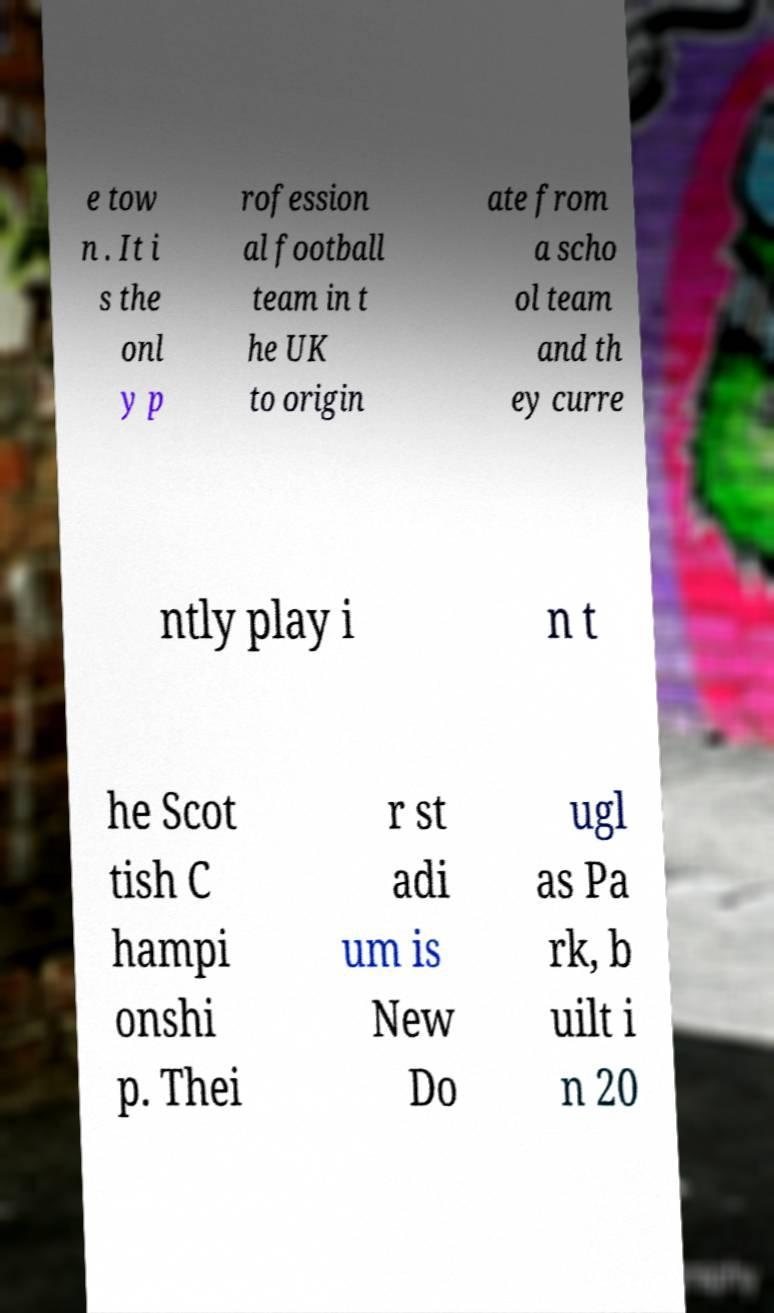For documentation purposes, I need the text within this image transcribed. Could you provide that? e tow n . It i s the onl y p rofession al football team in t he UK to origin ate from a scho ol team and th ey curre ntly play i n t he Scot tish C hampi onshi p. Thei r st adi um is New Do ugl as Pa rk, b uilt i n 20 